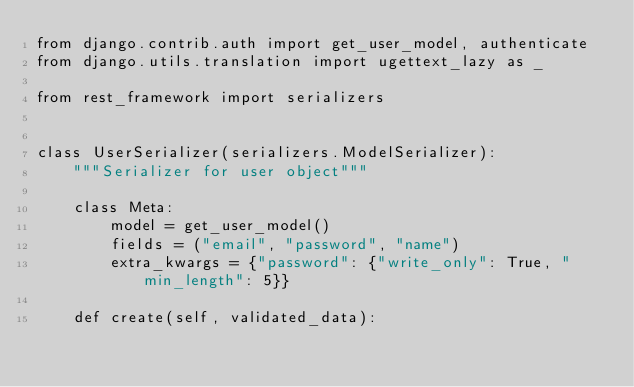<code> <loc_0><loc_0><loc_500><loc_500><_Python_>from django.contrib.auth import get_user_model, authenticate
from django.utils.translation import ugettext_lazy as _

from rest_framework import serializers


class UserSerializer(serializers.ModelSerializer):
    """Serializer for user object"""

    class Meta:
        model = get_user_model()
        fields = ("email", "password", "name")
        extra_kwargs = {"password": {"write_only": True, "min_length": 5}}

    def create(self, validated_data):</code> 